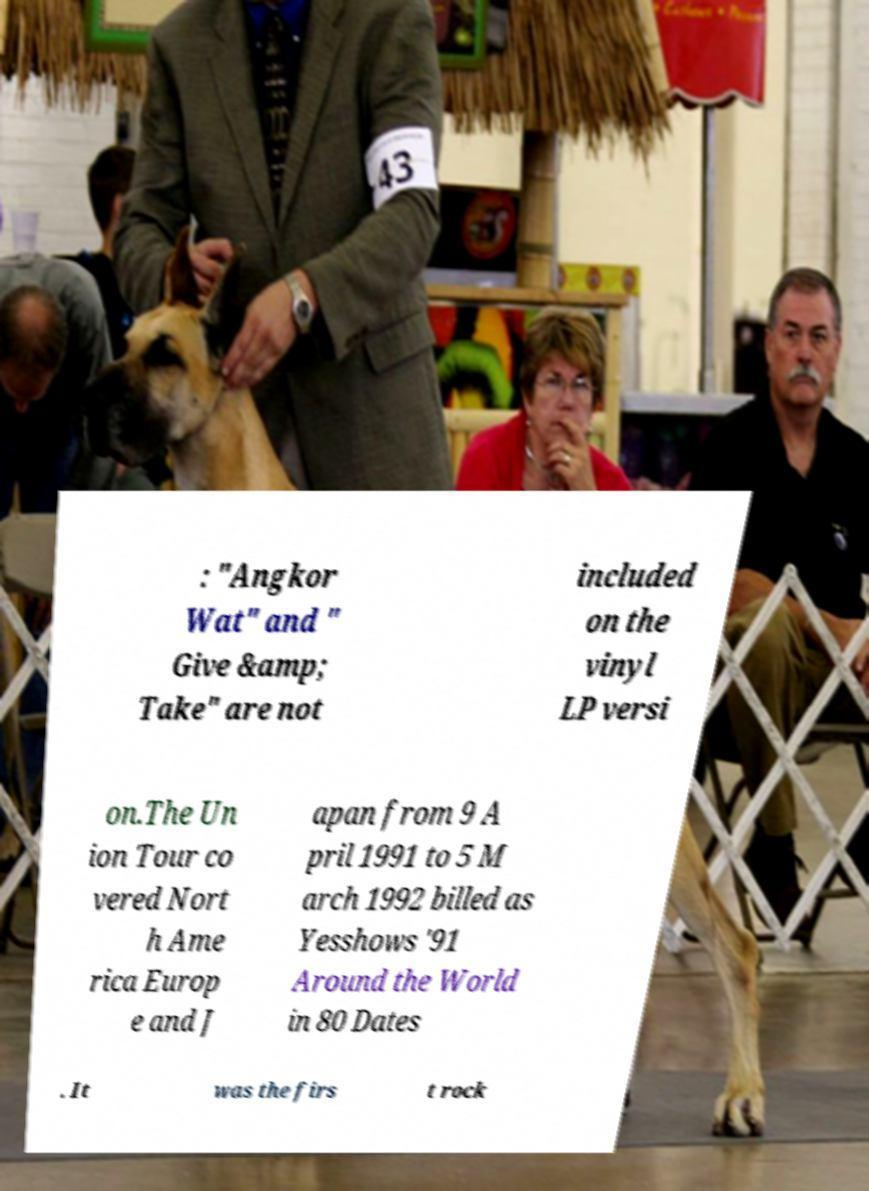Can you read and provide the text displayed in the image?This photo seems to have some interesting text. Can you extract and type it out for me? : "Angkor Wat" and " Give &amp; Take" are not included on the vinyl LP versi on.The Un ion Tour co vered Nort h Ame rica Europ e and J apan from 9 A pril 1991 to 5 M arch 1992 billed as Yesshows '91 Around the World in 80 Dates . It was the firs t rock 